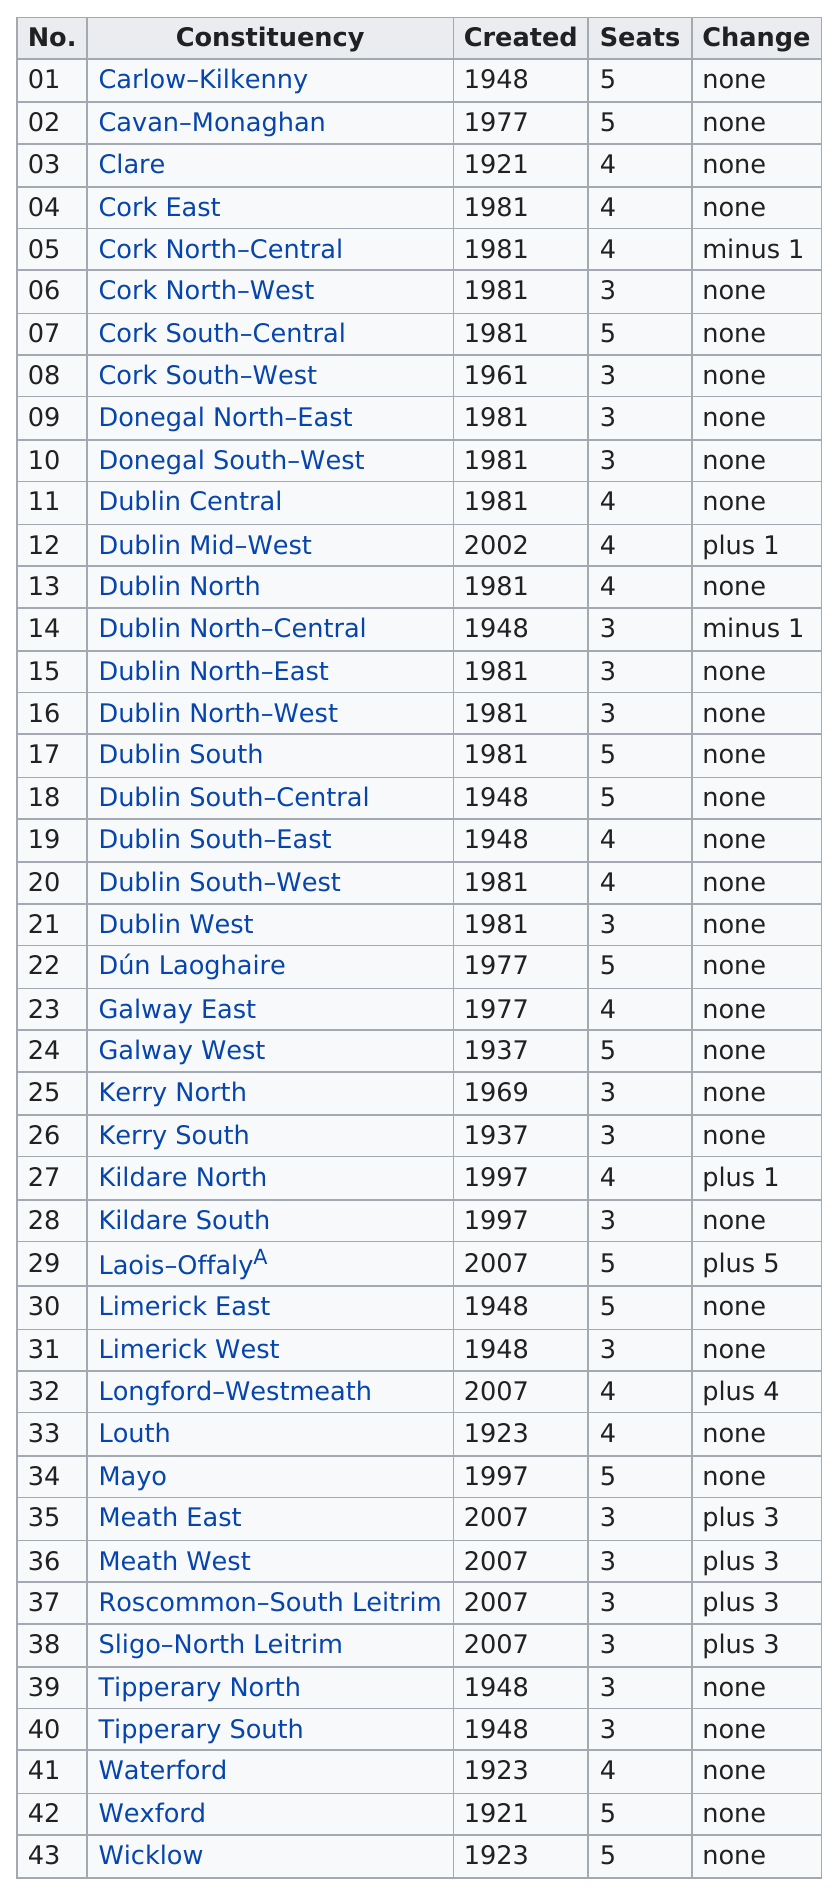Point out several critical features in this image. Carlow-Kilkenny is listed as the top constituency. There are 7 constituencies that are older than Carlow-Kilkenny. Out of the 10 constituencies, how many have a change other than 'none'? Between 1981 and 2012, Cork North-Central and Cork North-West were both constituencies. In the 1900s, only 7 constituencies were created. 